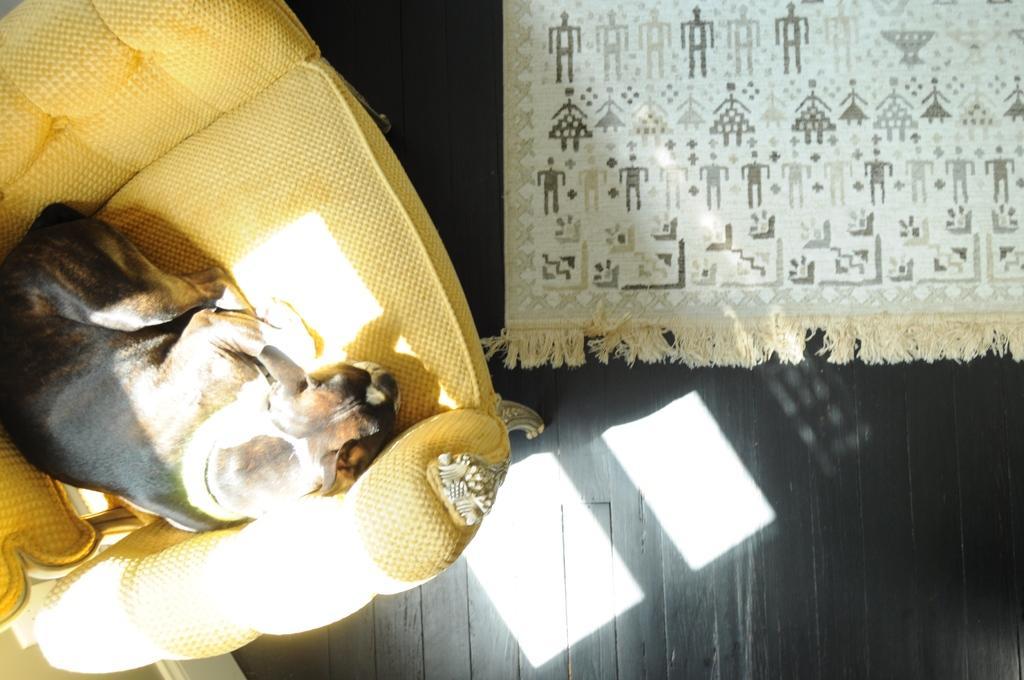In one or two sentences, can you explain what this image depicts? In this image I can see a dog visible on couch on the left side and I can see a carpet visible on right side. 